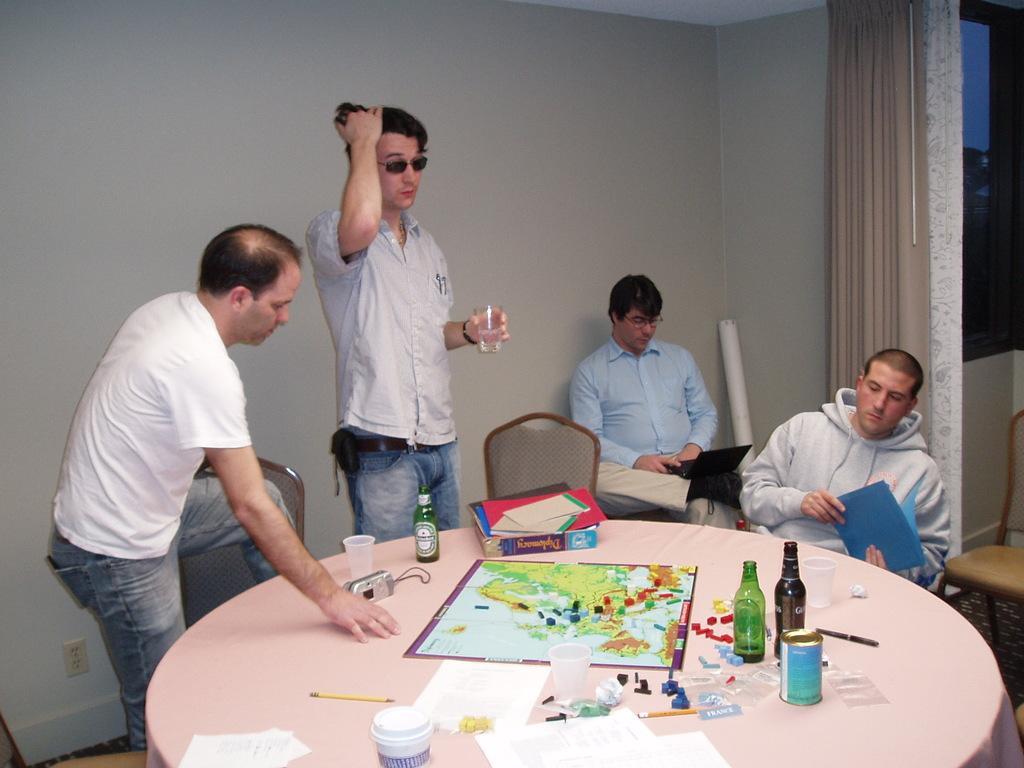Please provide a concise description of this image. In this image I see 4 men, in which 2 of them are sitting and other 2 are standing , I can see few chairs and a table on which there are bottles, cups and few things on it. In the background I see the wall and the curtain. 